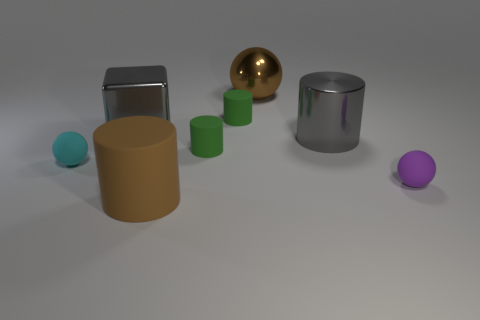There is a big cylinder that is the same color as the big metallic cube; what material is it?
Your response must be concise. Metal. Is there a brown metal thing that has the same size as the cyan thing?
Provide a short and direct response. No. The small matte thing on the left side of the brown cylinder is what color?
Give a very brief answer. Cyan. There is a big gray metallic thing that is on the right side of the large rubber cylinder; are there any big gray things that are on the left side of it?
Ensure brevity in your answer.  Yes. What number of other objects are the same color as the big metallic cube?
Offer a terse response. 1. There is a brown thing in front of the metallic cube; is its size the same as the brown object behind the tiny purple matte thing?
Offer a terse response. Yes. There is a metal object to the left of the large brown thing in front of the cyan thing; what is its size?
Provide a succinct answer. Large. What is the thing that is in front of the metal cylinder and to the left of the brown cylinder made of?
Your answer should be compact. Rubber. The metallic cube has what color?
Ensure brevity in your answer.  Gray. Are there any other things that are made of the same material as the tiny purple object?
Give a very brief answer. Yes. 